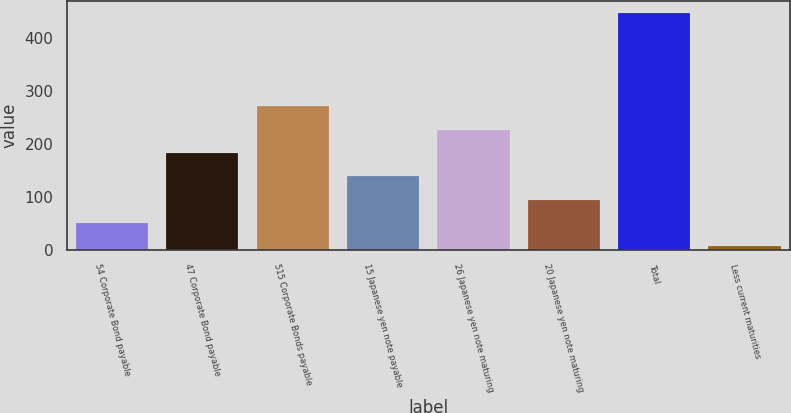Convert chart. <chart><loc_0><loc_0><loc_500><loc_500><bar_chart><fcel>54 Corporate Bond payable<fcel>47 Corporate Bond payable<fcel>515 Corporate Bonds payable<fcel>15 Japanese yen note payable<fcel>26 Japanese yen note maturing<fcel>20 Japanese yen note maturing<fcel>Total<fcel>Less current maturities<nl><fcel>50.41<fcel>182.74<fcel>270.96<fcel>138.63<fcel>226.85<fcel>94.52<fcel>447.4<fcel>6.3<nl></chart> 